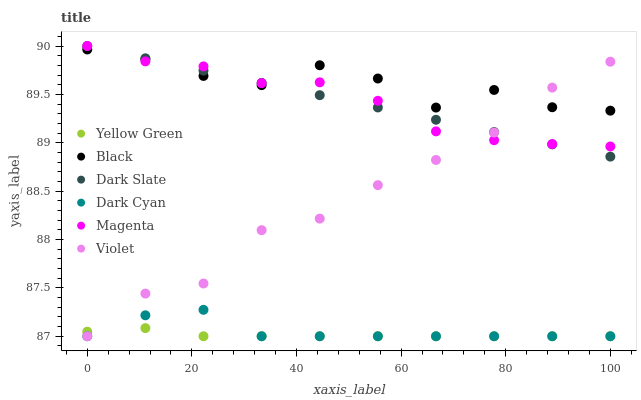Does Yellow Green have the minimum area under the curve?
Answer yes or no. Yes. Does Black have the maximum area under the curve?
Answer yes or no. Yes. Does Dark Slate have the minimum area under the curve?
Answer yes or no. No. Does Dark Slate have the maximum area under the curve?
Answer yes or no. No. Is Dark Slate the smoothest?
Answer yes or no. Yes. Is Black the roughest?
Answer yes or no. Yes. Is Black the smoothest?
Answer yes or no. No. Is Dark Slate the roughest?
Answer yes or no. No. Does Yellow Green have the lowest value?
Answer yes or no. Yes. Does Dark Slate have the lowest value?
Answer yes or no. No. Does Magenta have the highest value?
Answer yes or no. Yes. Does Black have the highest value?
Answer yes or no. No. Is Yellow Green less than Black?
Answer yes or no. Yes. Is Black greater than Dark Cyan?
Answer yes or no. Yes. Does Dark Slate intersect Violet?
Answer yes or no. Yes. Is Dark Slate less than Violet?
Answer yes or no. No. Is Dark Slate greater than Violet?
Answer yes or no. No. Does Yellow Green intersect Black?
Answer yes or no. No. 